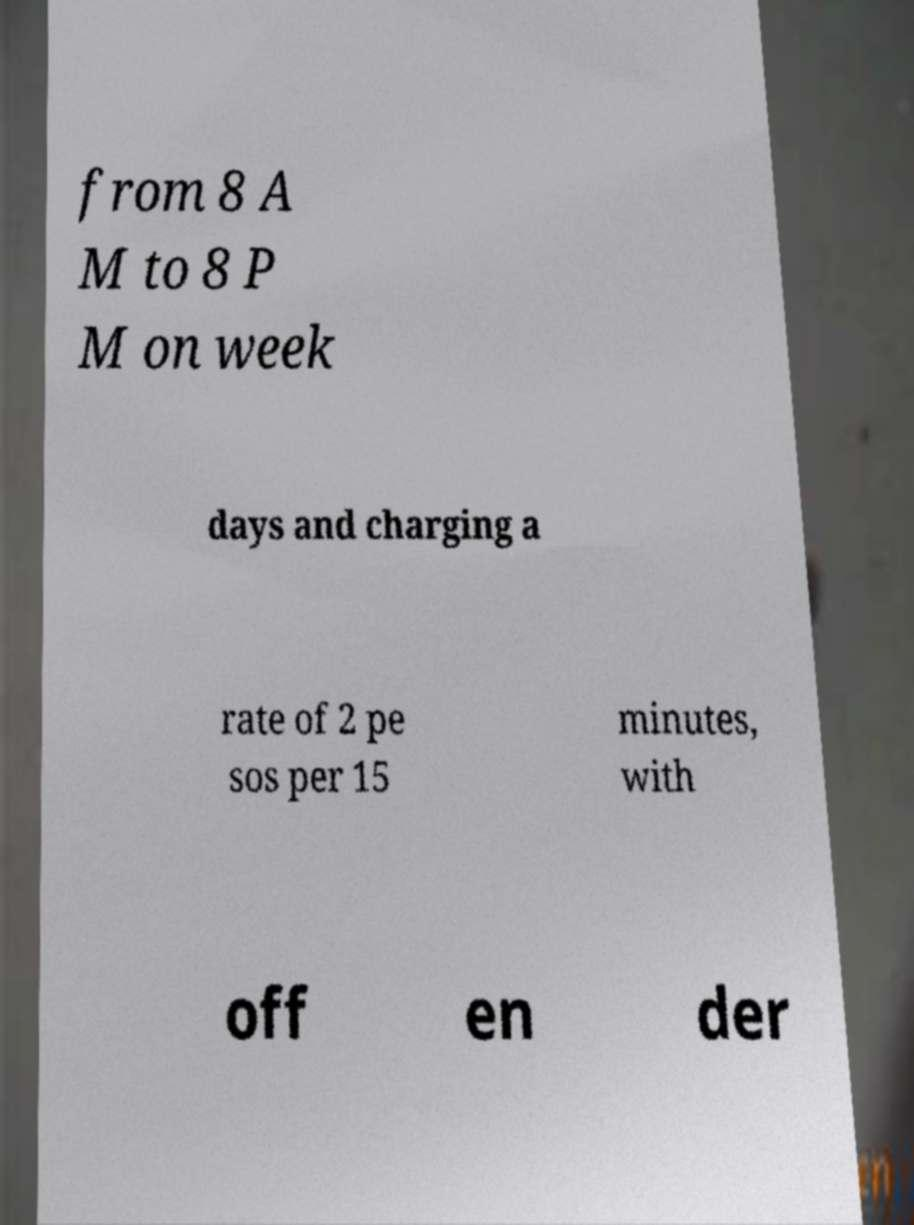Can you accurately transcribe the text from the provided image for me? from 8 A M to 8 P M on week days and charging a rate of 2 pe sos per 15 minutes, with off en der 